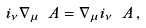<formula> <loc_0><loc_0><loc_500><loc_500>i _ { \nu } \nabla _ { \mu } \ A = \nabla _ { \mu } i _ { \nu } \ A \, ,</formula> 